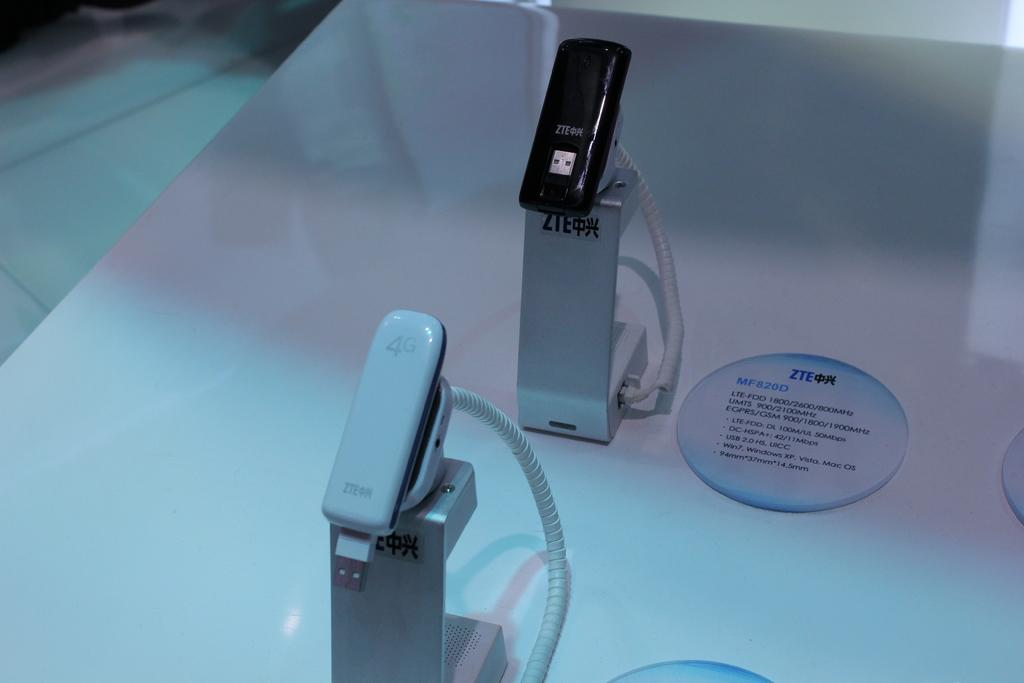<image>
Offer a succinct explanation of the picture presented. a zte logo that is next to some gadgets 